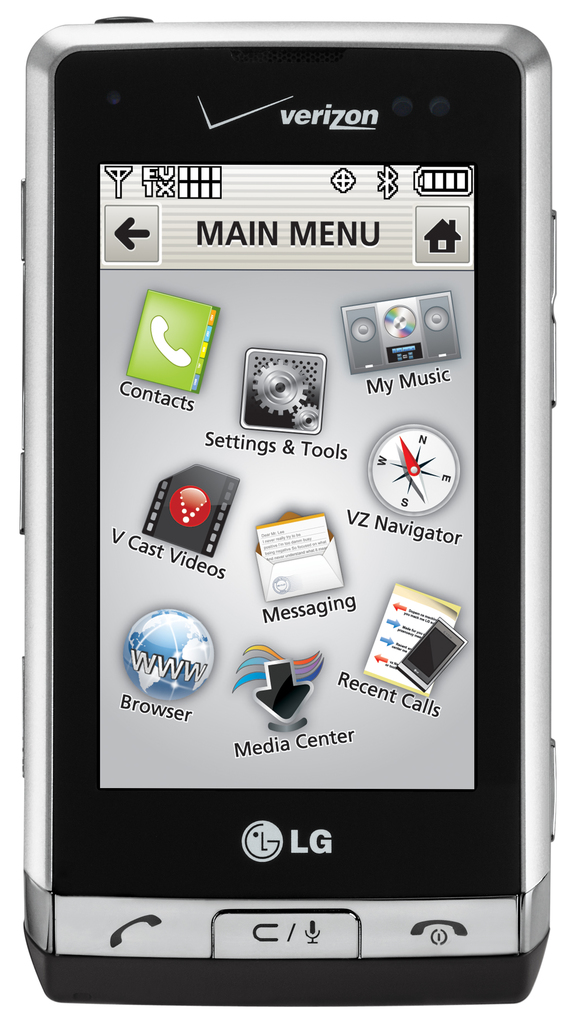Is there anything unique about the interface design shown in the menu? The interface design displayed on the phone's main menu incorporates a mix of colorful and simple icons with a glossy finish which was trendy during the late 2000s. It includes unique elements like a centered main menu for easy navigation, somewhat emulating the contemporaneous emerging touchscreen interfaces. 